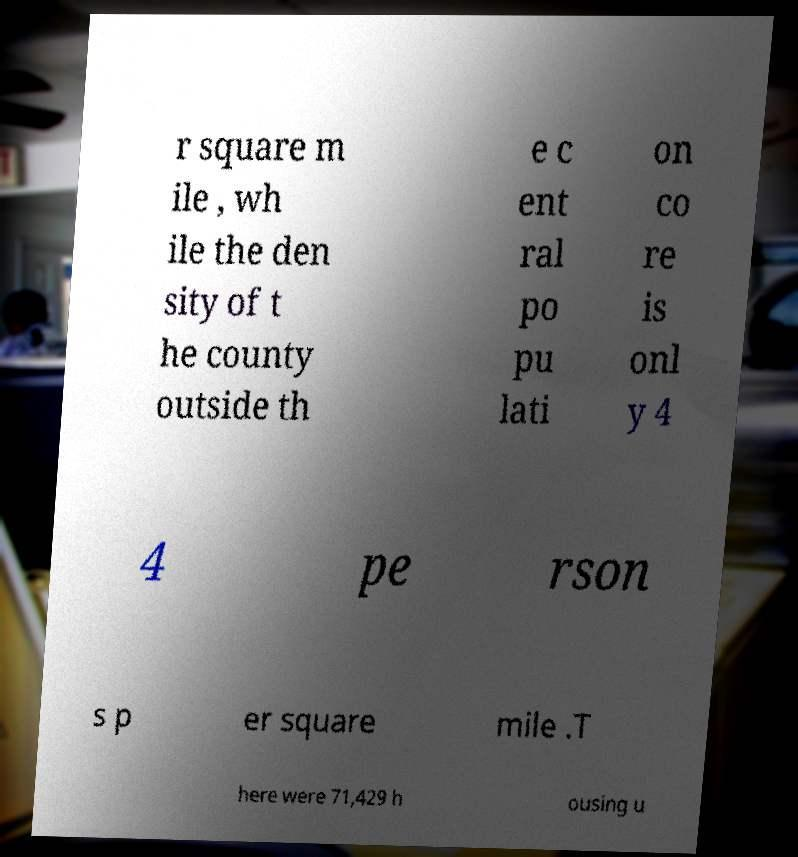For documentation purposes, I need the text within this image transcribed. Could you provide that? r square m ile , wh ile the den sity of t he county outside th e c ent ral po pu lati on co re is onl y 4 4 pe rson s p er square mile .T here were 71,429 h ousing u 